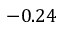<formula> <loc_0><loc_0><loc_500><loc_500>- 0 . 2 4</formula> 